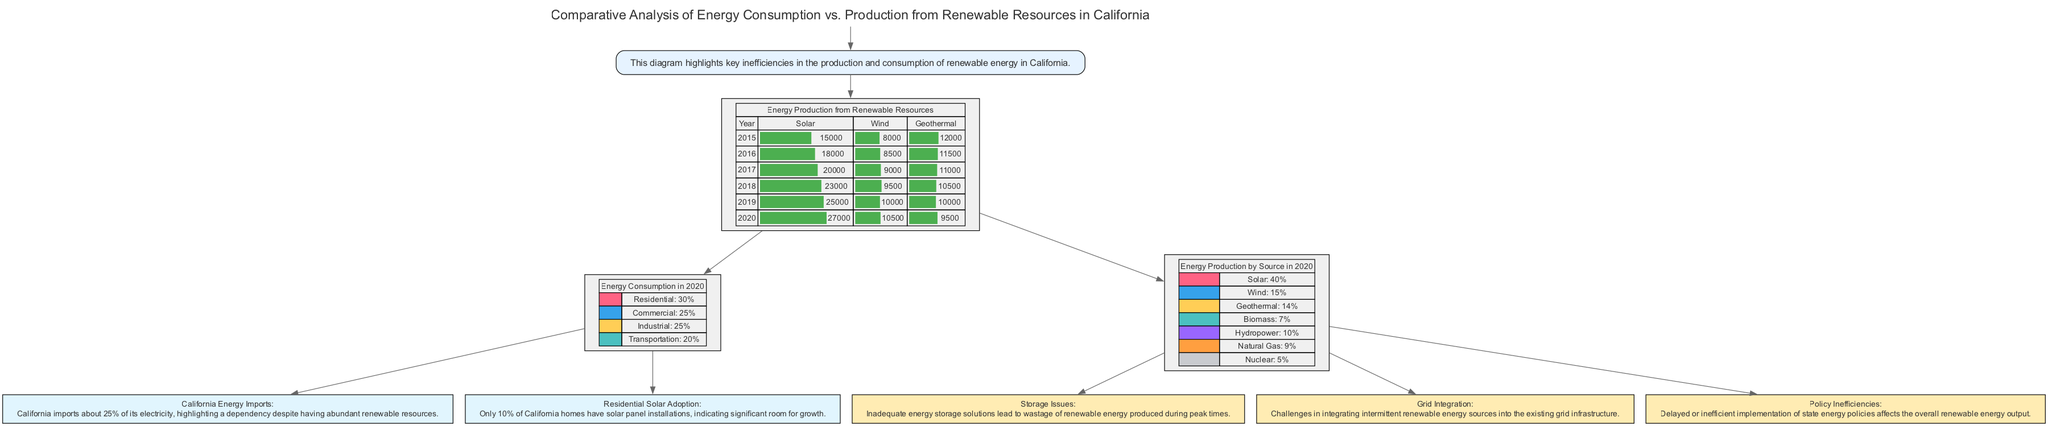What is the title of the diagram? The title of the diagram is displayed prominently at the top.
Answer: Comparative Analysis of Energy Consumption vs. Production from Renewable Resources in California In which year did solar energy production reach 27,000 GWh? By examining the bar graph data, 27,000 GWh for solar energy production corresponds to the year 2020.
Answer: 2020 What percentage of energy consumption in 2020 was attributed to the transportation sector? The pie chart for Energy Consumption in 2020 shows that transportation accounts for 20% of the total energy consumption.
Answer: 20% Which renewable energy source had the highest production in 2020? The pie chart titled "Energy Production by Source in 2020" indicates that solar energy had the highest production at 40%.
Answer: Solar What are the key inefficiencies identified in the diagram? The diagram lists three key inefficiencies, which are Storage Issues, Grid Integration, and Policy Inefficiencies, highlighting potential areas of concern.
Answer: Storage Issues, Grid Integration, Policy Inefficiencies How much electricity does California import according to the facts presented? The fact section states that California imports about 25% of its electricity, which reflects on its dependency on outside sources.
Answer: 25% What is the total number of renewable energy production sources mentioned in 2020? The pie chart for Energy Production by Source in 2020 mentions six sources: Solar, Wind, Geothermal, Biomass, Hydropower, and Natural Gas.
Answer: Six How much energy was produced from wind in 2018? Referring to the bar graph, wind energy production in 2018 was recorded at 9,500 GWh.
Answer: 9500 GWh What is the description for Storage Issues under key inefficiencies? The description for Storage Issues states that inadequate energy storage solutions lead to wastage of renewable energy produced during peak times.
Answer: Inadequate energy storage solutions lead to wastage of renewable energy produced during peak times 